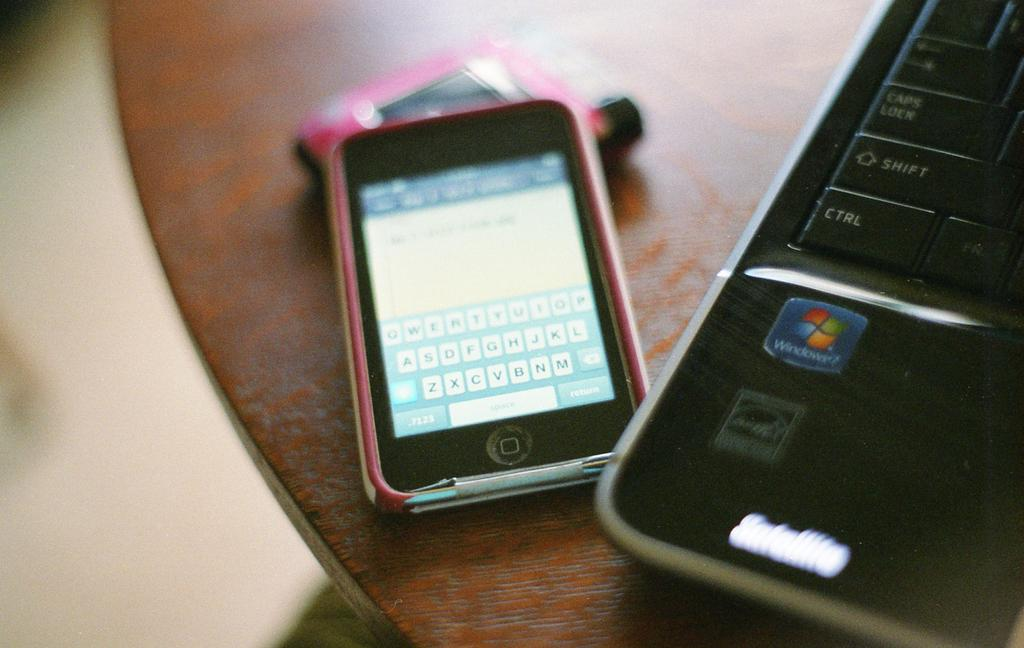<image>
Provide a brief description of the given image. small pink phone on message screen next to satellite laptop running windows 